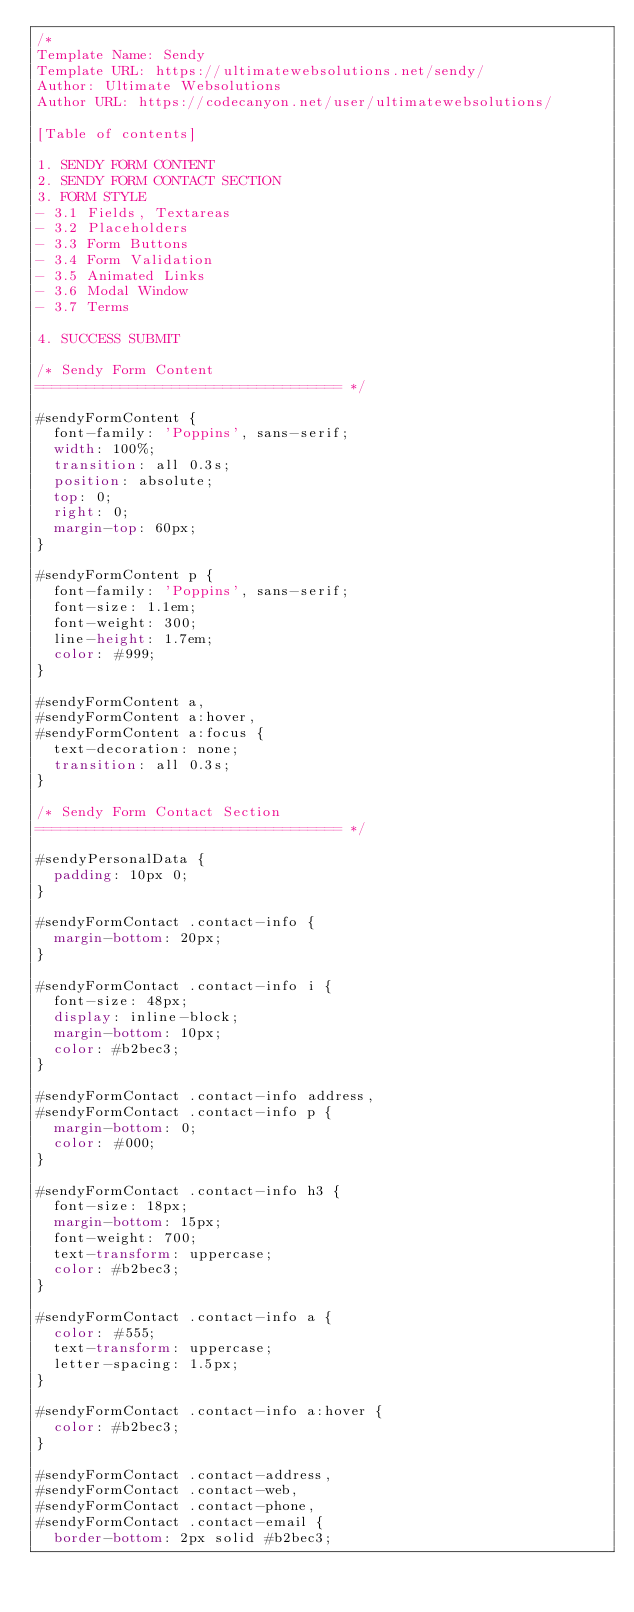<code> <loc_0><loc_0><loc_500><loc_500><_CSS_>/*
Template Name: Sendy 
Template URL: https://ultimatewebsolutions.net/sendy/
Author: Ultimate Websolutions
Author URL: https://codecanyon.net/user/ultimatewebsolutions/

[Table of contents] 

1. SENDY FORM CONTENT
2. SENDY FORM CONTACT SECTION
3. FORM STYLE
- 3.1 Fields, Textareas
- 3.2 Placeholders
- 3.3 Form Buttons
- 3.4 Form Validation
- 3.5 Animated Links
- 3.6 Modal Window
- 3.7 Terms

4. SUCCESS SUBMIT

/* Sendy Form Content
==================================== */

#sendyFormContent {
  font-family: 'Poppins', sans-serif;
  width: 100%;
  transition: all 0.3s;
	position: absolute;
	top: 0;
  right: 0;
  margin-top: 60px; 
}

#sendyFormContent p {
  font-family: 'Poppins', sans-serif;
  font-size: 1.1em;
	font-weight: 300;
	line-height: 1.7em;
	color: #999;
}

#sendyFormContent a,
#sendyFormContent a:hover,
#sendyFormContent a:focus { 
  text-decoration: none;
	transition: all 0.3s; 
}

/* Sendy Form Contact Section
==================================== */

#sendyPersonalData {
	padding: 10px 0;
}

#sendyFormContact .contact-info {
	margin-bottom: 20px;	
}

#sendyFormContact .contact-info i {
  font-size: 48px;
  display: inline-block;
  margin-bottom: 10px;
  color: #b2bec3;
}

#sendyFormContact .contact-info address,
#sendyFormContact .contact-info p {
  margin-bottom: 0;
  color: #000;
}

#sendyFormContact .contact-info h3 {
  font-size: 18px;
  margin-bottom: 15px;
  font-weight: 700;
  text-transform: uppercase;
  color: #b2bec3;
}

#sendyFormContact .contact-info a {
  color: #555;
  text-transform: uppercase;
  letter-spacing: 1.5px;  
}

#sendyFormContact .contact-info a:hover {
  color: #b2bec3;
}

#sendyFormContact .contact-address,
#sendyFormContact .contact-web,
#sendyFormContact .contact-phone,
#sendyFormContact .contact-email {	
	border-bottom: 2px solid #b2bec3;	</code> 